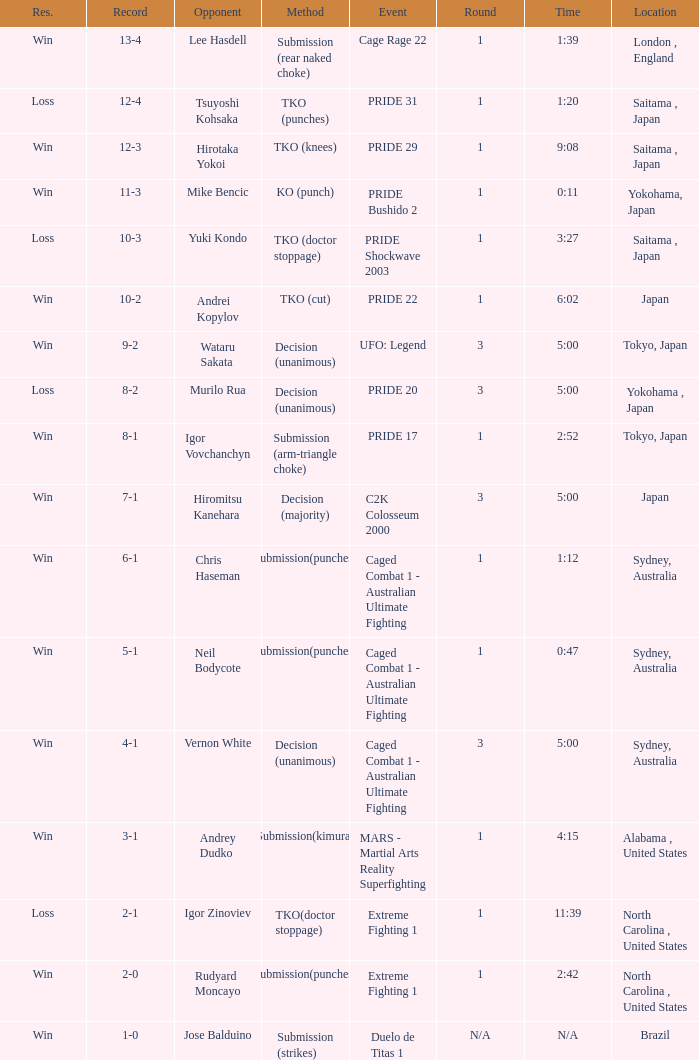Which Record has the Res of win with the Event of extreme fighting 1? 2-0. 